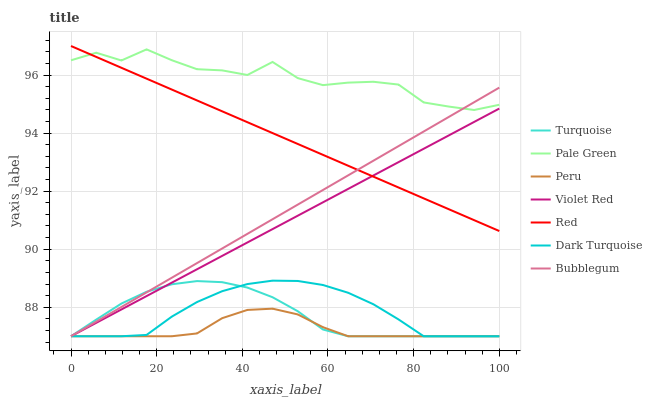Does Peru have the minimum area under the curve?
Answer yes or no. Yes. Does Pale Green have the maximum area under the curve?
Answer yes or no. Yes. Does Dark Turquoise have the minimum area under the curve?
Answer yes or no. No. Does Dark Turquoise have the maximum area under the curve?
Answer yes or no. No. Is Red the smoothest?
Answer yes or no. Yes. Is Pale Green the roughest?
Answer yes or no. Yes. Is Dark Turquoise the smoothest?
Answer yes or no. No. Is Dark Turquoise the roughest?
Answer yes or no. No. Does Turquoise have the lowest value?
Answer yes or no. Yes. Does Pale Green have the lowest value?
Answer yes or no. No. Does Red have the highest value?
Answer yes or no. Yes. Does Dark Turquoise have the highest value?
Answer yes or no. No. Is Violet Red less than Pale Green?
Answer yes or no. Yes. Is Pale Green greater than Turquoise?
Answer yes or no. Yes. Does Dark Turquoise intersect Turquoise?
Answer yes or no. Yes. Is Dark Turquoise less than Turquoise?
Answer yes or no. No. Is Dark Turquoise greater than Turquoise?
Answer yes or no. No. Does Violet Red intersect Pale Green?
Answer yes or no. No. 